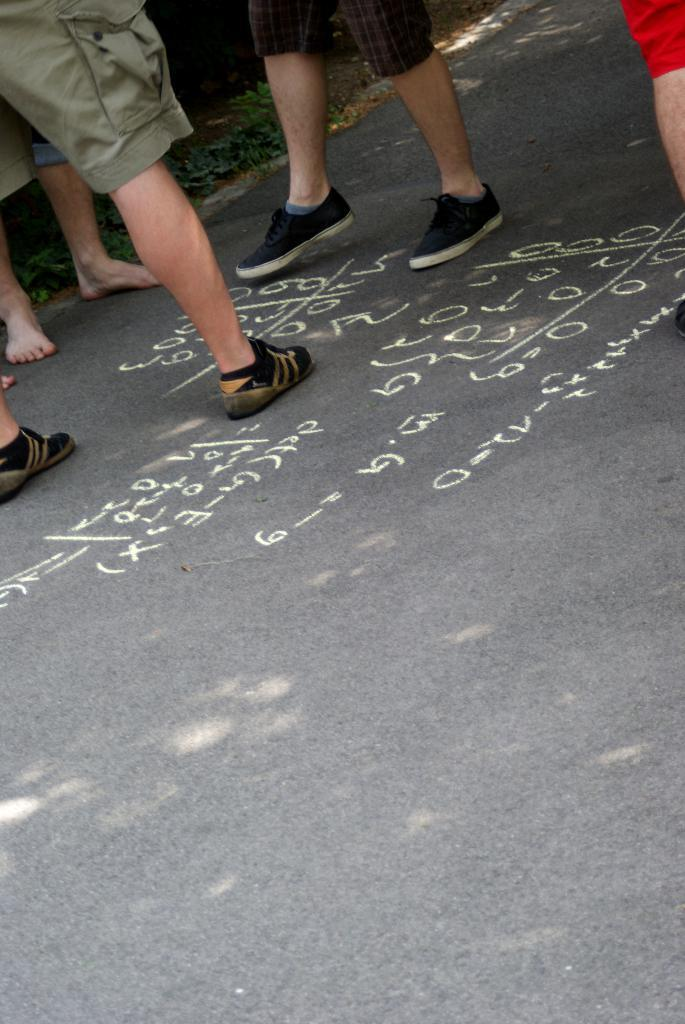Where was the image taken? The image was taken on a road. What can be seen on the road in the image? There are people standing on the road, and numbers are present on the road. What type of vegetation is visible behind the people? Grass is visible on the ground behind the people. What type of poison is being used by the people in the image? There is no poison present in the image; it features people standing on a road with numbers on it and grass visible in the background. 